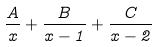<formula> <loc_0><loc_0><loc_500><loc_500>\frac { A } { x } + \frac { B } { x - 1 } + \frac { C } { x - 2 }</formula> 